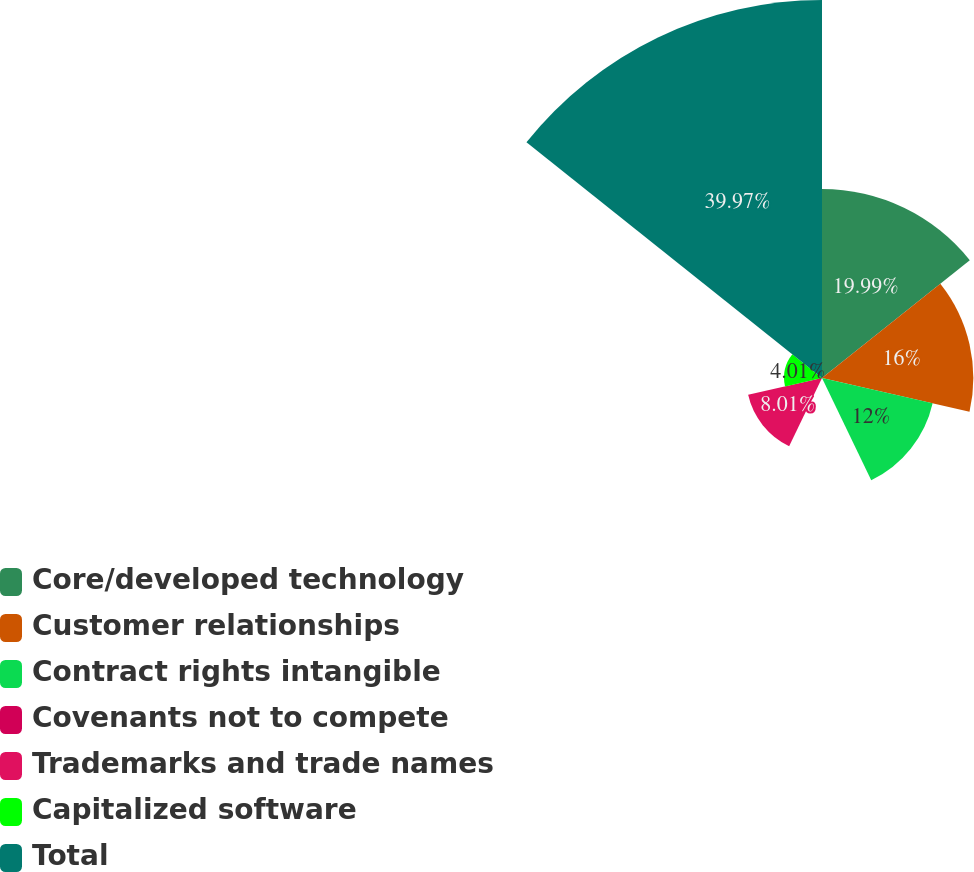Convert chart to OTSL. <chart><loc_0><loc_0><loc_500><loc_500><pie_chart><fcel>Core/developed technology<fcel>Customer relationships<fcel>Contract rights intangible<fcel>Covenants not to compete<fcel>Trademarks and trade names<fcel>Capitalized software<fcel>Total<nl><fcel>19.99%<fcel>16.0%<fcel>12.0%<fcel>0.02%<fcel>8.01%<fcel>4.01%<fcel>39.97%<nl></chart> 